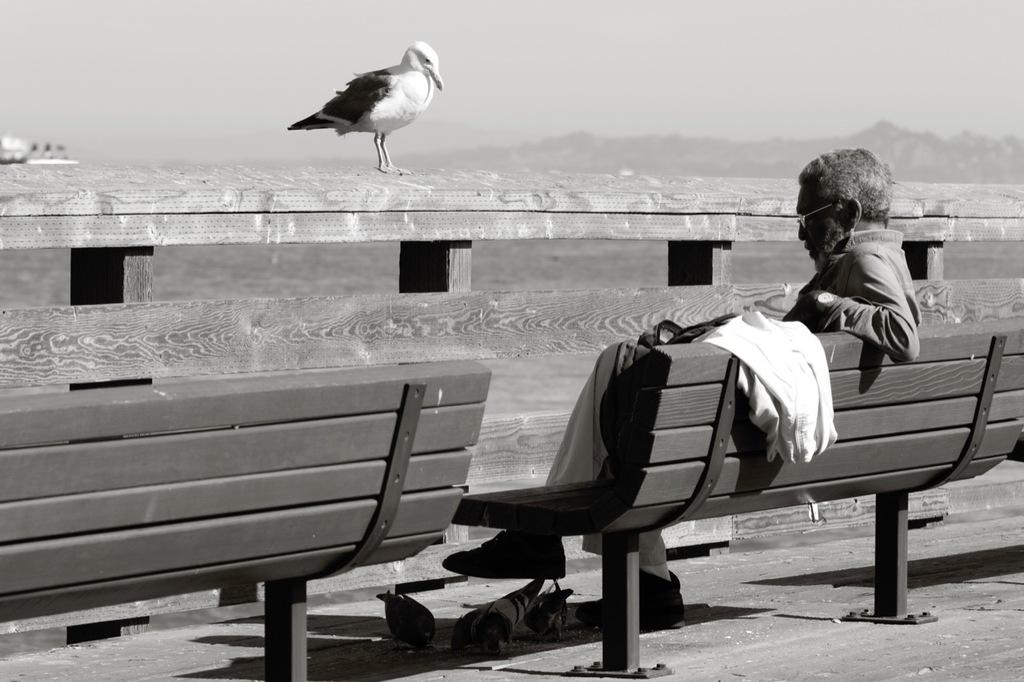What is the color scheme of the image? The image is black and white. What can be seen on the fence in the image? There is a bird on a fence in the image. What is the person in the image doing? A person is sitting on a bench in the image. What is on the bench besides the person? There is a jacket on the bench in the image. What else can be seen on the ground in the image? There are birds on the floor in the image. What type of friction can be observed between the potato and the bench in the image? There is no potato present in the image, so no friction can be observed between a potato and the bench. 